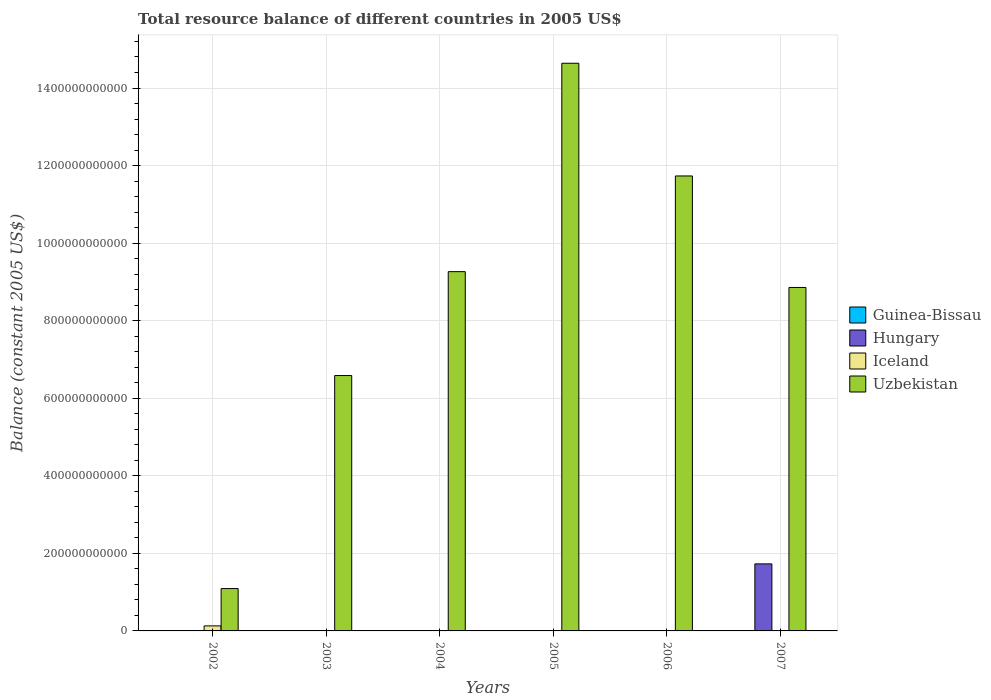How many different coloured bars are there?
Provide a succinct answer. 3. How many bars are there on the 4th tick from the left?
Keep it short and to the point. 1. In how many cases, is the number of bars for a given year not equal to the number of legend labels?
Give a very brief answer. 6. What is the total resource balance in Uzbekistan in 2007?
Offer a terse response. 8.86e+11. Across all years, what is the maximum total resource balance in Uzbekistan?
Keep it short and to the point. 1.46e+12. Across all years, what is the minimum total resource balance in Guinea-Bissau?
Keep it short and to the point. 0. What is the total total resource balance in Iceland in the graph?
Your answer should be very brief. 1.29e+1. What is the difference between the total resource balance in Uzbekistan in 2002 and that in 2004?
Keep it short and to the point. -8.17e+11. What is the difference between the total resource balance in Hungary in 2005 and the total resource balance in Guinea-Bissau in 2002?
Provide a short and direct response. 0. What is the average total resource balance in Iceland per year?
Your answer should be very brief. 2.16e+09. In the year 2007, what is the difference between the total resource balance in Uzbekistan and total resource balance in Hungary?
Provide a succinct answer. 7.13e+11. In how many years, is the total resource balance in Guinea-Bissau greater than 360000000000 US$?
Ensure brevity in your answer.  0. What is the ratio of the total resource balance in Uzbekistan in 2003 to that in 2005?
Provide a short and direct response. 0.45. Is the total resource balance in Uzbekistan in 2003 less than that in 2006?
Offer a very short reply. Yes. What is the difference between the highest and the second highest total resource balance in Uzbekistan?
Provide a succinct answer. 2.91e+11. What is the difference between the highest and the lowest total resource balance in Uzbekistan?
Offer a terse response. 1.35e+12. In how many years, is the total resource balance in Guinea-Bissau greater than the average total resource balance in Guinea-Bissau taken over all years?
Make the answer very short. 0. Is the sum of the total resource balance in Uzbekistan in 2003 and 2005 greater than the maximum total resource balance in Guinea-Bissau across all years?
Your response must be concise. Yes. Is it the case that in every year, the sum of the total resource balance in Guinea-Bissau and total resource balance in Uzbekistan is greater than the total resource balance in Hungary?
Your answer should be very brief. Yes. How many bars are there?
Your response must be concise. 8. Are all the bars in the graph horizontal?
Keep it short and to the point. No. How many years are there in the graph?
Your answer should be compact. 6. What is the difference between two consecutive major ticks on the Y-axis?
Your response must be concise. 2.00e+11. Are the values on the major ticks of Y-axis written in scientific E-notation?
Give a very brief answer. No. Does the graph contain any zero values?
Make the answer very short. Yes. What is the title of the graph?
Provide a succinct answer. Total resource balance of different countries in 2005 US$. Does "Macedonia" appear as one of the legend labels in the graph?
Provide a succinct answer. No. What is the label or title of the X-axis?
Give a very brief answer. Years. What is the label or title of the Y-axis?
Your answer should be very brief. Balance (constant 2005 US$). What is the Balance (constant 2005 US$) in Guinea-Bissau in 2002?
Your answer should be compact. 0. What is the Balance (constant 2005 US$) of Hungary in 2002?
Provide a short and direct response. 0. What is the Balance (constant 2005 US$) of Iceland in 2002?
Give a very brief answer. 1.29e+1. What is the Balance (constant 2005 US$) in Uzbekistan in 2002?
Your answer should be compact. 1.09e+11. What is the Balance (constant 2005 US$) in Iceland in 2003?
Your answer should be compact. 0. What is the Balance (constant 2005 US$) in Uzbekistan in 2003?
Make the answer very short. 6.59e+11. What is the Balance (constant 2005 US$) in Uzbekistan in 2004?
Your response must be concise. 9.26e+11. What is the Balance (constant 2005 US$) in Iceland in 2005?
Ensure brevity in your answer.  0. What is the Balance (constant 2005 US$) of Uzbekistan in 2005?
Make the answer very short. 1.46e+12. What is the Balance (constant 2005 US$) in Guinea-Bissau in 2006?
Make the answer very short. 0. What is the Balance (constant 2005 US$) in Hungary in 2006?
Provide a succinct answer. 0. What is the Balance (constant 2005 US$) of Uzbekistan in 2006?
Provide a succinct answer. 1.17e+12. What is the Balance (constant 2005 US$) in Guinea-Bissau in 2007?
Make the answer very short. 0. What is the Balance (constant 2005 US$) of Hungary in 2007?
Offer a very short reply. 1.73e+11. What is the Balance (constant 2005 US$) of Uzbekistan in 2007?
Your response must be concise. 8.86e+11. Across all years, what is the maximum Balance (constant 2005 US$) of Hungary?
Your answer should be very brief. 1.73e+11. Across all years, what is the maximum Balance (constant 2005 US$) of Iceland?
Provide a short and direct response. 1.29e+1. Across all years, what is the maximum Balance (constant 2005 US$) of Uzbekistan?
Your response must be concise. 1.46e+12. Across all years, what is the minimum Balance (constant 2005 US$) of Hungary?
Your answer should be compact. 0. Across all years, what is the minimum Balance (constant 2005 US$) in Uzbekistan?
Offer a very short reply. 1.09e+11. What is the total Balance (constant 2005 US$) of Hungary in the graph?
Provide a succinct answer. 1.73e+11. What is the total Balance (constant 2005 US$) of Iceland in the graph?
Your answer should be compact. 1.29e+1. What is the total Balance (constant 2005 US$) of Uzbekistan in the graph?
Give a very brief answer. 5.22e+12. What is the difference between the Balance (constant 2005 US$) of Uzbekistan in 2002 and that in 2003?
Offer a very short reply. -5.49e+11. What is the difference between the Balance (constant 2005 US$) of Uzbekistan in 2002 and that in 2004?
Keep it short and to the point. -8.17e+11. What is the difference between the Balance (constant 2005 US$) in Uzbekistan in 2002 and that in 2005?
Your response must be concise. -1.35e+12. What is the difference between the Balance (constant 2005 US$) in Uzbekistan in 2002 and that in 2006?
Your answer should be compact. -1.06e+12. What is the difference between the Balance (constant 2005 US$) in Uzbekistan in 2002 and that in 2007?
Keep it short and to the point. -7.76e+11. What is the difference between the Balance (constant 2005 US$) in Uzbekistan in 2003 and that in 2004?
Offer a terse response. -2.68e+11. What is the difference between the Balance (constant 2005 US$) of Uzbekistan in 2003 and that in 2005?
Give a very brief answer. -8.05e+11. What is the difference between the Balance (constant 2005 US$) of Uzbekistan in 2003 and that in 2006?
Keep it short and to the point. -5.15e+11. What is the difference between the Balance (constant 2005 US$) of Uzbekistan in 2003 and that in 2007?
Your answer should be very brief. -2.27e+11. What is the difference between the Balance (constant 2005 US$) in Uzbekistan in 2004 and that in 2005?
Keep it short and to the point. -5.37e+11. What is the difference between the Balance (constant 2005 US$) in Uzbekistan in 2004 and that in 2006?
Your answer should be compact. -2.47e+11. What is the difference between the Balance (constant 2005 US$) of Uzbekistan in 2004 and that in 2007?
Provide a short and direct response. 4.08e+1. What is the difference between the Balance (constant 2005 US$) in Uzbekistan in 2005 and that in 2006?
Provide a succinct answer. 2.91e+11. What is the difference between the Balance (constant 2005 US$) of Uzbekistan in 2005 and that in 2007?
Make the answer very short. 5.78e+11. What is the difference between the Balance (constant 2005 US$) of Uzbekistan in 2006 and that in 2007?
Ensure brevity in your answer.  2.88e+11. What is the difference between the Balance (constant 2005 US$) in Iceland in 2002 and the Balance (constant 2005 US$) in Uzbekistan in 2003?
Make the answer very short. -6.46e+11. What is the difference between the Balance (constant 2005 US$) in Iceland in 2002 and the Balance (constant 2005 US$) in Uzbekistan in 2004?
Your response must be concise. -9.14e+11. What is the difference between the Balance (constant 2005 US$) in Iceland in 2002 and the Balance (constant 2005 US$) in Uzbekistan in 2005?
Keep it short and to the point. -1.45e+12. What is the difference between the Balance (constant 2005 US$) in Iceland in 2002 and the Balance (constant 2005 US$) in Uzbekistan in 2006?
Offer a terse response. -1.16e+12. What is the difference between the Balance (constant 2005 US$) in Iceland in 2002 and the Balance (constant 2005 US$) in Uzbekistan in 2007?
Provide a short and direct response. -8.73e+11. What is the average Balance (constant 2005 US$) in Guinea-Bissau per year?
Offer a terse response. 0. What is the average Balance (constant 2005 US$) in Hungary per year?
Your response must be concise. 2.88e+1. What is the average Balance (constant 2005 US$) of Iceland per year?
Provide a short and direct response. 2.16e+09. What is the average Balance (constant 2005 US$) in Uzbekistan per year?
Your answer should be very brief. 8.69e+11. In the year 2002, what is the difference between the Balance (constant 2005 US$) in Iceland and Balance (constant 2005 US$) in Uzbekistan?
Your response must be concise. -9.63e+1. In the year 2007, what is the difference between the Balance (constant 2005 US$) in Hungary and Balance (constant 2005 US$) in Uzbekistan?
Offer a very short reply. -7.13e+11. What is the ratio of the Balance (constant 2005 US$) of Uzbekistan in 2002 to that in 2003?
Offer a very short reply. 0.17. What is the ratio of the Balance (constant 2005 US$) in Uzbekistan in 2002 to that in 2004?
Give a very brief answer. 0.12. What is the ratio of the Balance (constant 2005 US$) in Uzbekistan in 2002 to that in 2005?
Offer a very short reply. 0.07. What is the ratio of the Balance (constant 2005 US$) in Uzbekistan in 2002 to that in 2006?
Your answer should be compact. 0.09. What is the ratio of the Balance (constant 2005 US$) of Uzbekistan in 2002 to that in 2007?
Offer a terse response. 0.12. What is the ratio of the Balance (constant 2005 US$) of Uzbekistan in 2003 to that in 2004?
Provide a succinct answer. 0.71. What is the ratio of the Balance (constant 2005 US$) in Uzbekistan in 2003 to that in 2005?
Offer a very short reply. 0.45. What is the ratio of the Balance (constant 2005 US$) in Uzbekistan in 2003 to that in 2006?
Make the answer very short. 0.56. What is the ratio of the Balance (constant 2005 US$) in Uzbekistan in 2003 to that in 2007?
Give a very brief answer. 0.74. What is the ratio of the Balance (constant 2005 US$) of Uzbekistan in 2004 to that in 2005?
Make the answer very short. 0.63. What is the ratio of the Balance (constant 2005 US$) of Uzbekistan in 2004 to that in 2006?
Offer a very short reply. 0.79. What is the ratio of the Balance (constant 2005 US$) in Uzbekistan in 2004 to that in 2007?
Make the answer very short. 1.05. What is the ratio of the Balance (constant 2005 US$) of Uzbekistan in 2005 to that in 2006?
Ensure brevity in your answer.  1.25. What is the ratio of the Balance (constant 2005 US$) in Uzbekistan in 2005 to that in 2007?
Give a very brief answer. 1.65. What is the ratio of the Balance (constant 2005 US$) of Uzbekistan in 2006 to that in 2007?
Ensure brevity in your answer.  1.32. What is the difference between the highest and the second highest Balance (constant 2005 US$) in Uzbekistan?
Your answer should be very brief. 2.91e+11. What is the difference between the highest and the lowest Balance (constant 2005 US$) of Hungary?
Give a very brief answer. 1.73e+11. What is the difference between the highest and the lowest Balance (constant 2005 US$) in Iceland?
Your answer should be compact. 1.29e+1. What is the difference between the highest and the lowest Balance (constant 2005 US$) in Uzbekistan?
Your answer should be compact. 1.35e+12. 